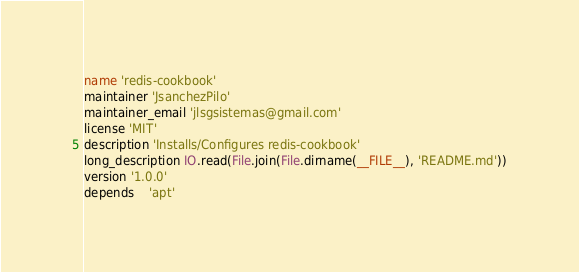<code> <loc_0><loc_0><loc_500><loc_500><_Ruby_>name 'redis-cookbook'
maintainer 'JsanchezPilo'
maintainer_email 'jlsgsistemas@gmail.com'
license 'MIT'
description 'Installs/Configures redis-cookbook'
long_description IO.read(File.join(File.dirname(__FILE__), 'README.md'))
version '1.0.0'
depends	'apt'
</code> 